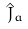<formula> <loc_0><loc_0><loc_500><loc_500>\hat { J } _ { a }</formula> 